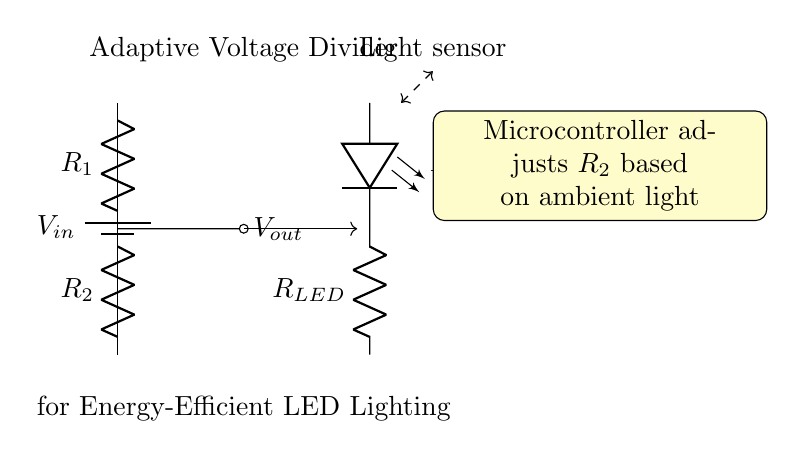What is the input voltage in this circuit? The input voltage is represented by the source labeled V_in, which supplies energy to the circuit.
Answer: V_in What components make up the voltage divider? The voltage divider consists of two resistors, R_1 and R_2, connected in series, along with a voltage input and output points.
Answer: R_1, R_2 How does the circuit adjust the resistance? The circuit uses a microcontroller to adjust R_2 based on ambient light conditions detected by a light sensor, which influences the output voltage for the LED.
Answer: Microcontroller What is the role of R_LED in this circuit? R_LED is used to limit the current flowing through the LED, ensuring it operates within safe parameters to prevent burning out.
Answer: Current limiter What would happen if R_1 is increased? Increasing R_1 will decrease the output voltage V_out across R_2 because the voltage divider formula indicates that an increase in the top resistor (R_1) leads to a smaller voltage across R_2 proportionally.
Answer: Decreased V_out What type of circuit is represented here? This circuit is a voltage divider, which is specifically designed to create a lower voltage output from a higher input voltage using resistors.
Answer: Voltage divider 